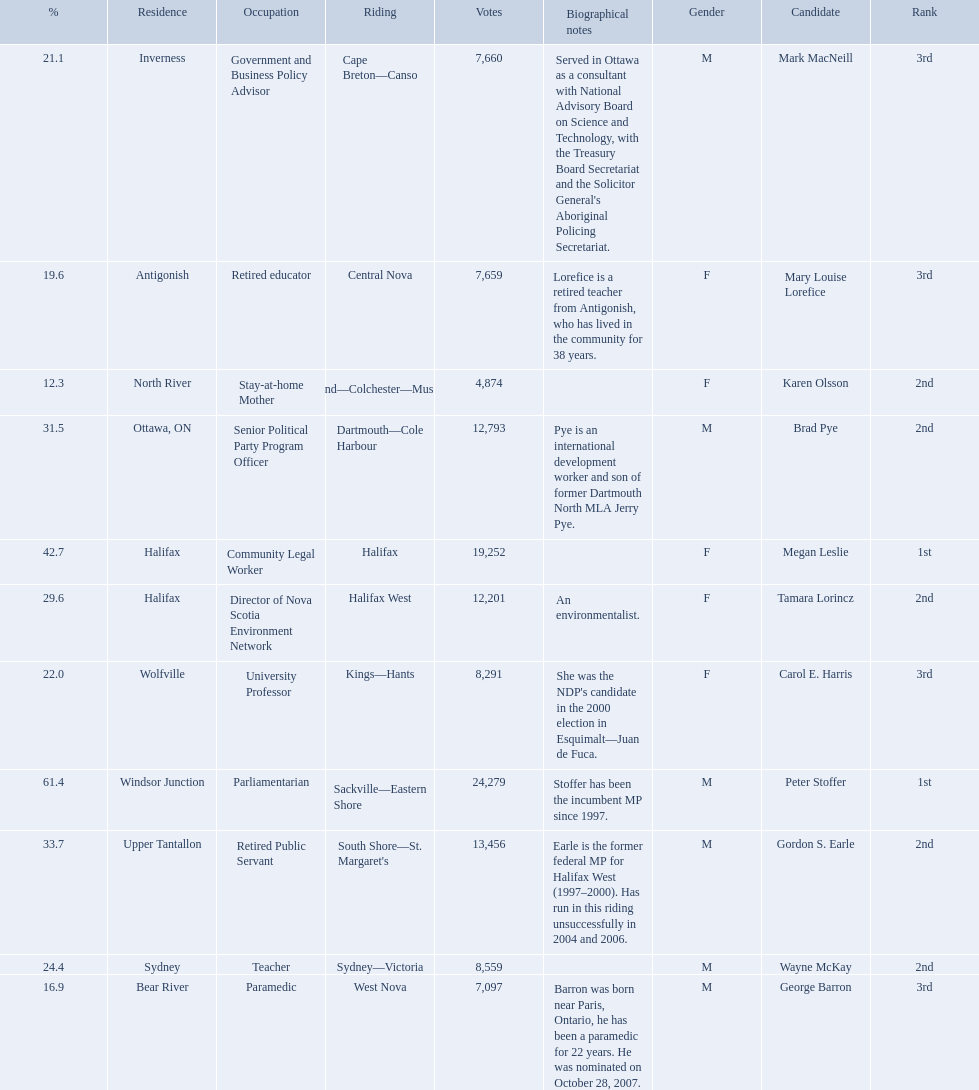Who are all the candidates? Mark MacNeill, Mary Louise Lorefice, Karen Olsson, Brad Pye, Megan Leslie, Tamara Lorincz, Carol E. Harris, Peter Stoffer, Gordon S. Earle, Wayne McKay, George Barron. How many votes did they receive? 7,660, 7,659, 4,874, 12,793, 19,252, 12,201, 8,291, 24,279, 13,456, 8,559, 7,097. And of those, how many were for megan leslie? 19,252. 